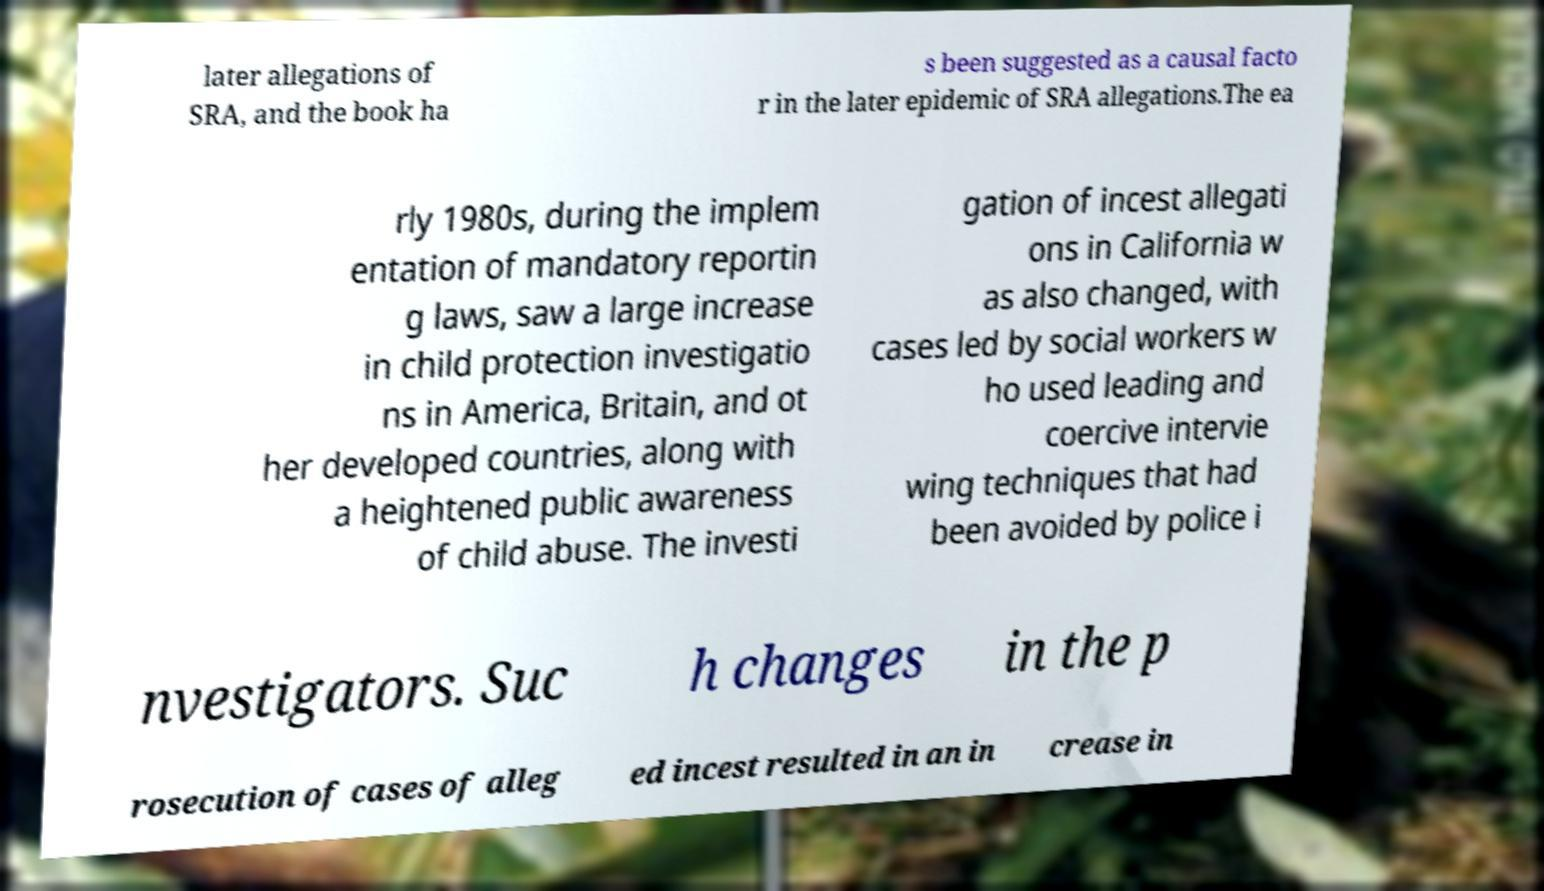Can you accurately transcribe the text from the provided image for me? later allegations of SRA, and the book ha s been suggested as a causal facto r in the later epidemic of SRA allegations.The ea rly 1980s, during the implem entation of mandatory reportin g laws, saw a large increase in child protection investigatio ns in America, Britain, and ot her developed countries, along with a heightened public awareness of child abuse. The investi gation of incest allegati ons in California w as also changed, with cases led by social workers w ho used leading and coercive intervie wing techniques that had been avoided by police i nvestigators. Suc h changes in the p rosecution of cases of alleg ed incest resulted in an in crease in 